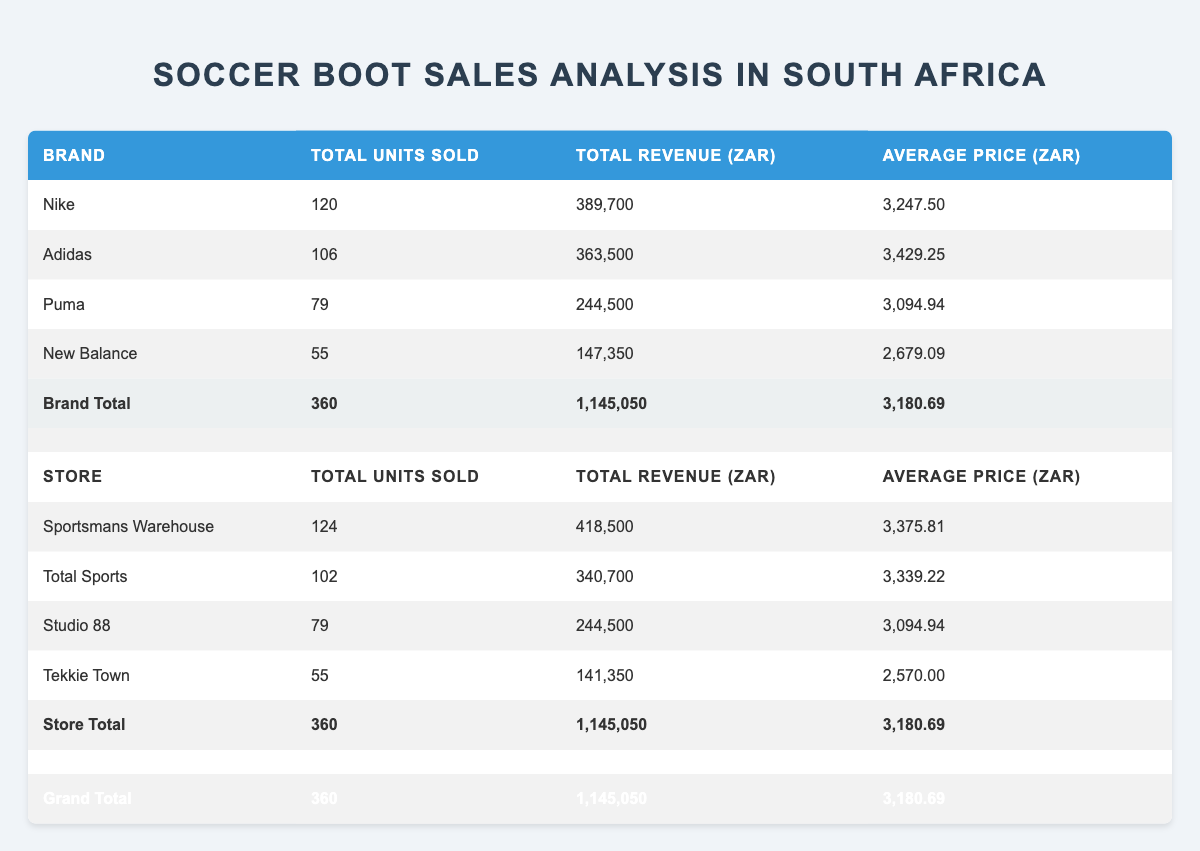What brand sold the highest number of soccer boots? The total units sold for each brand are listed in the table: Nike (120), Adidas (106), Puma (79), and New Balance (55). Nike has the highest total, so it sold the most units.
Answer: Nike What was the total revenue from Adidas soccer boots? The total revenue for Adidas is given in the table as 363,500 ZAR.
Answer: 363,500 ZAR Which store had the lowest total units sold? The total units sold for each store are: Sportsmans Warehouse (124), Total Sports (102), Studio 88 (79), and Tekkie Town (55). Tekkie Town sold the least units, making it the lowest.
Answer: Tekkie Town What is the average price of Nike soccer boots sold? The total revenue from Nike is 389,700 ZAR, and 120 units were sold. To find the average price, divide the total revenue by the total units: 389,700/ZAR 120 = ZAR 3,247.50.
Answer: ZAR 3,247.50 Is the average price of New Balance soccer boots less than ZAR 2,800? The average price for New Balance boots is given in the table as ZAR 2,679.09, which is less than ZAR 2,800, so the statement is true.
Answer: Yes Which brand had a total revenue exceeding 300,000 ZAR? The total revenues for each brand are Nike (389,700 ZAR), Adidas (363,500 ZAR), Puma (244,500 ZAR), and New Balance (147,350 ZAR). Nike and Adidas both exceed 300,000 ZAR.
Answer: Nike and Adidas What was the combined total units sold by Sportsmans Warehouse and Studio 88? Sportsmans Warehouse sold 124 units and Studio 88 sold 79 units. Adding these gives: 124 + 79 = 203 units.
Answer: 203 What is the total average price across all brands? The average prices for all brands are: Nike (3,247.50 ZAR), Adidas (3,429.25 ZAR), Puma (3,094.94 ZAR), and New Balance (2,679.09 ZAR). To find the total average price, sum them up (3,247.50 + 3,429.25 + 3,094.94 + 2,679.09) = 12,450.78 ZAR and divide by 4: 12,450.78 ZAR / 4 = 3,112.69 ZAR.
Answer: ZAR 3,112.69 During which month was the highest units sold for Nike products? From the data, Sportsmans Warehouse sold 47 units of Nike's Mercurial Vapor 14 in September, which is the highest among Nike products for any month.
Answer: September 